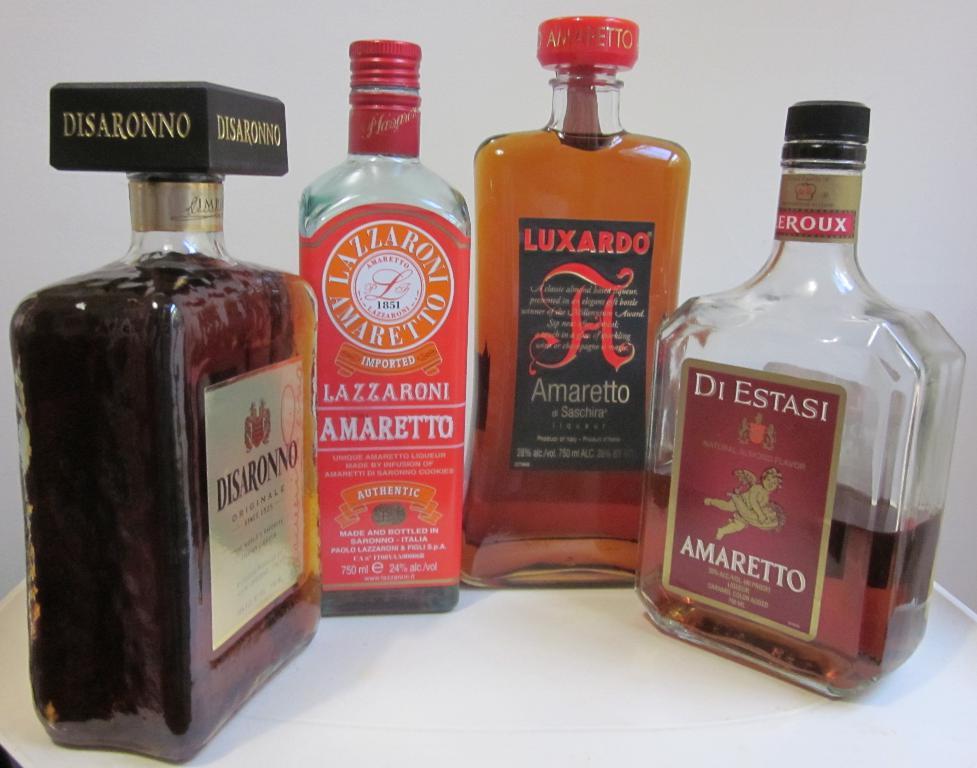What is the name of the bottle on the far right?
Give a very brief answer. Di estasi. What is the drink on the very left?
Your response must be concise. Disaronno. 